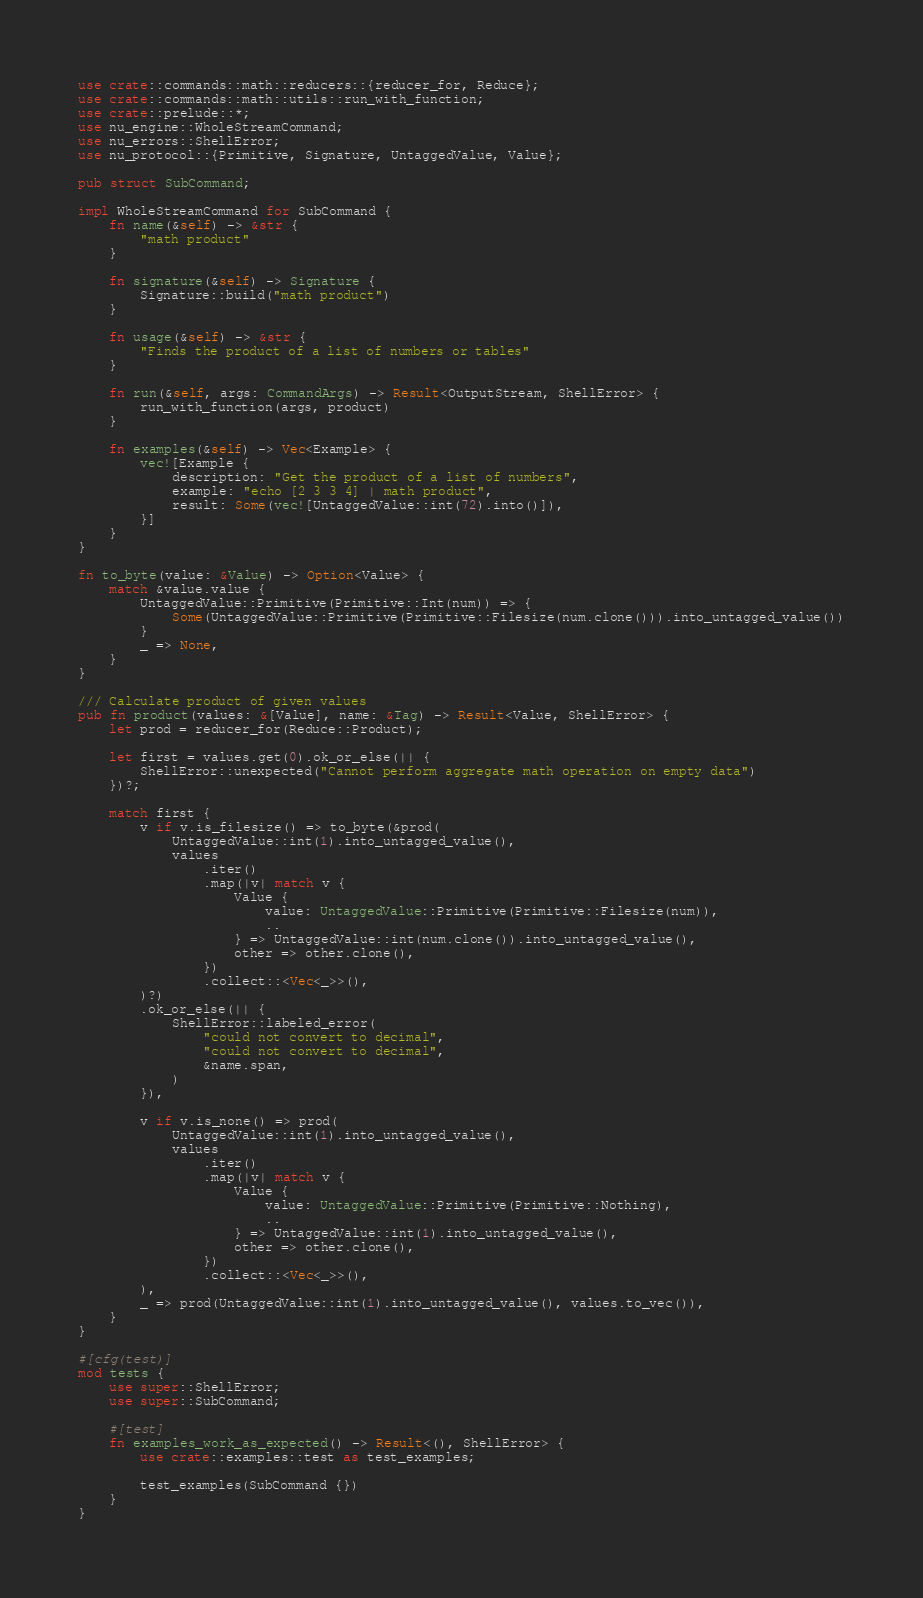<code> <loc_0><loc_0><loc_500><loc_500><_Rust_>use crate::commands::math::reducers::{reducer_for, Reduce};
use crate::commands::math::utils::run_with_function;
use crate::prelude::*;
use nu_engine::WholeStreamCommand;
use nu_errors::ShellError;
use nu_protocol::{Primitive, Signature, UntaggedValue, Value};

pub struct SubCommand;

impl WholeStreamCommand for SubCommand {
    fn name(&self) -> &str {
        "math product"
    }

    fn signature(&self) -> Signature {
        Signature::build("math product")
    }

    fn usage(&self) -> &str {
        "Finds the product of a list of numbers or tables"
    }

    fn run(&self, args: CommandArgs) -> Result<OutputStream, ShellError> {
        run_with_function(args, product)
    }

    fn examples(&self) -> Vec<Example> {
        vec![Example {
            description: "Get the product of a list of numbers",
            example: "echo [2 3 3 4] | math product",
            result: Some(vec![UntaggedValue::int(72).into()]),
        }]
    }
}

fn to_byte(value: &Value) -> Option<Value> {
    match &value.value {
        UntaggedValue::Primitive(Primitive::Int(num)) => {
            Some(UntaggedValue::Primitive(Primitive::Filesize(num.clone())).into_untagged_value())
        }
        _ => None,
    }
}

/// Calculate product of given values
pub fn product(values: &[Value], name: &Tag) -> Result<Value, ShellError> {
    let prod = reducer_for(Reduce::Product);

    let first = values.get(0).ok_or_else(|| {
        ShellError::unexpected("Cannot perform aggregate math operation on empty data")
    })?;

    match first {
        v if v.is_filesize() => to_byte(&prod(
            UntaggedValue::int(1).into_untagged_value(),
            values
                .iter()
                .map(|v| match v {
                    Value {
                        value: UntaggedValue::Primitive(Primitive::Filesize(num)),
                        ..
                    } => UntaggedValue::int(num.clone()).into_untagged_value(),
                    other => other.clone(),
                })
                .collect::<Vec<_>>(),
        )?)
        .ok_or_else(|| {
            ShellError::labeled_error(
                "could not convert to decimal",
                "could not convert to decimal",
                &name.span,
            )
        }),

        v if v.is_none() => prod(
            UntaggedValue::int(1).into_untagged_value(),
            values
                .iter()
                .map(|v| match v {
                    Value {
                        value: UntaggedValue::Primitive(Primitive::Nothing),
                        ..
                    } => UntaggedValue::int(1).into_untagged_value(),
                    other => other.clone(),
                })
                .collect::<Vec<_>>(),
        ),
        _ => prod(UntaggedValue::int(1).into_untagged_value(), values.to_vec()),
    }
}

#[cfg(test)]
mod tests {
    use super::ShellError;
    use super::SubCommand;

    #[test]
    fn examples_work_as_expected() -> Result<(), ShellError> {
        use crate::examples::test as test_examples;

        test_examples(SubCommand {})
    }
}
</code> 